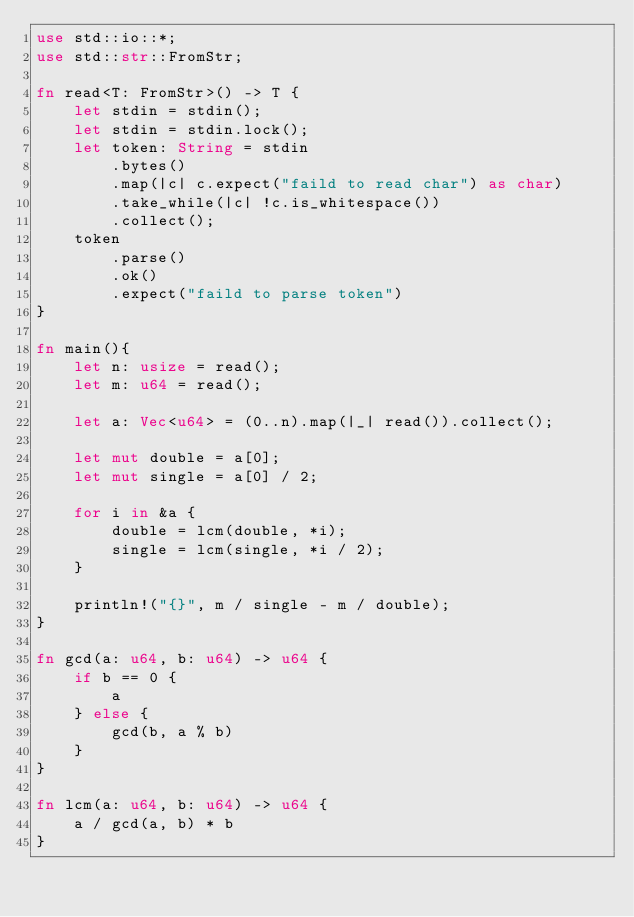Convert code to text. <code><loc_0><loc_0><loc_500><loc_500><_Rust_>use std::io::*;
use std::str::FromStr;

fn read<T: FromStr>() -> T {
    let stdin = stdin();
    let stdin = stdin.lock();
    let token: String = stdin
        .bytes()
        .map(|c| c.expect("faild to read char") as char)
        .take_while(|c| !c.is_whitespace())
        .collect();
    token
        .parse()
        .ok()
        .expect("faild to parse token")
}

fn main(){
    let n: usize = read();
    let m: u64 = read();

    let a: Vec<u64> = (0..n).map(|_| read()).collect();

    let mut double = a[0];
    let mut single = a[0] / 2;

    for i in &a {
        double = lcm(double, *i);
        single = lcm(single, *i / 2);
    }

    println!("{}", m / single - m / double);
}

fn gcd(a: u64, b: u64) -> u64 {
    if b == 0 {
        a
    } else {
        gcd(b, a % b)
    }
}

fn lcm(a: u64, b: u64) -> u64 {
    a / gcd(a, b) * b
}
</code> 